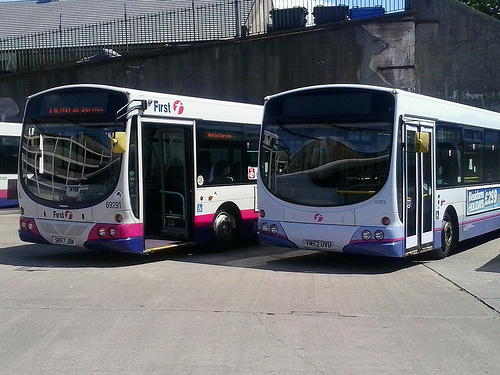What seems to be the condition of the buses in the image? The buses in the image appear to be stationary and parked in a depot or bus station. They show signs of regular use but seem to be well-maintained, judging by the intact exteriors and clean appearance. Do these buses look like they are currently in service? Based on the image, these buses do not appear to be in active service. They look parked with no passengers aboard, which could indicate they are out of service temporarily or awaiting their next scheduled route. 